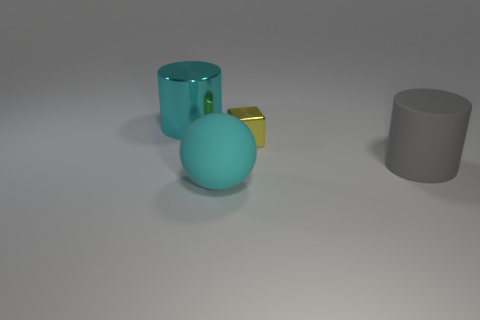What is the material of the big cylinder that is the same color as the big sphere?
Offer a very short reply. Metal. The yellow object has what size?
Give a very brief answer. Small. Is the big metallic cylinder the same color as the rubber sphere?
Your answer should be very brief. Yes. There is a cyan thing behind the cyan matte ball; is its size the same as the rubber sphere?
Your response must be concise. Yes. There is a big cyan thing behind the cyan matte ball; what is its material?
Offer a very short reply. Metal. Are there more big cyan things than cyan metal cylinders?
Ensure brevity in your answer.  Yes. What number of objects are either big cylinders left of the gray rubber thing or cyan metallic things?
Provide a succinct answer. 1. There is a big cyan cylinder that is behind the block; how many cyan cylinders are on the left side of it?
Provide a succinct answer. 0. How big is the yellow thing that is behind the large cylinder in front of the metallic thing that is to the left of the metallic cube?
Your response must be concise. Small. Do the large thing behind the tiny shiny object and the rubber sphere have the same color?
Offer a terse response. Yes. 